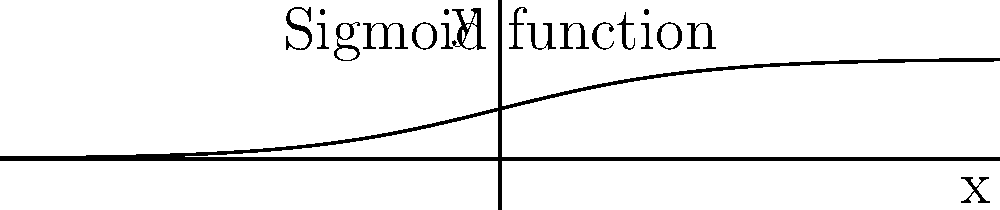In a convolutional neural network (CNN) for classifying medical images of cell structures, which activation function is represented by the graph above, and why is it particularly useful in the output layer for binary classification tasks? 1. The graph represents the sigmoid function, defined as $f(x) = \frac{1}{1 + e^{-x}}$.

2. Characteristics of the sigmoid function:
   a. Output range: (0, 1)
   b. S-shaped curve
   c. Smoothly differentiable

3. Usefulness in binary classification:
   a. Output interpreted as probability (0 to 1 range)
   b. Clear decision boundary at 0.5
   c. Smooth gradient for backpropagation

4. In CNNs for medical image classification:
   a. Last layer uses sigmoid for binary tasks (e.g., benign vs. malignant)
   b. Softmax is used for multi-class problems instead

5. Limitations:
   a. Vanishing gradient problem in deep networks
   b. Not zero-centered, which can cause zig-zagging in gradient descent

6. Despite limitations, sigmoid remains useful in output layers for binary classification in medical image analysis due to its probabilistic interpretation.
Answer: Sigmoid function; outputs probabilities (0-1) for binary classification 